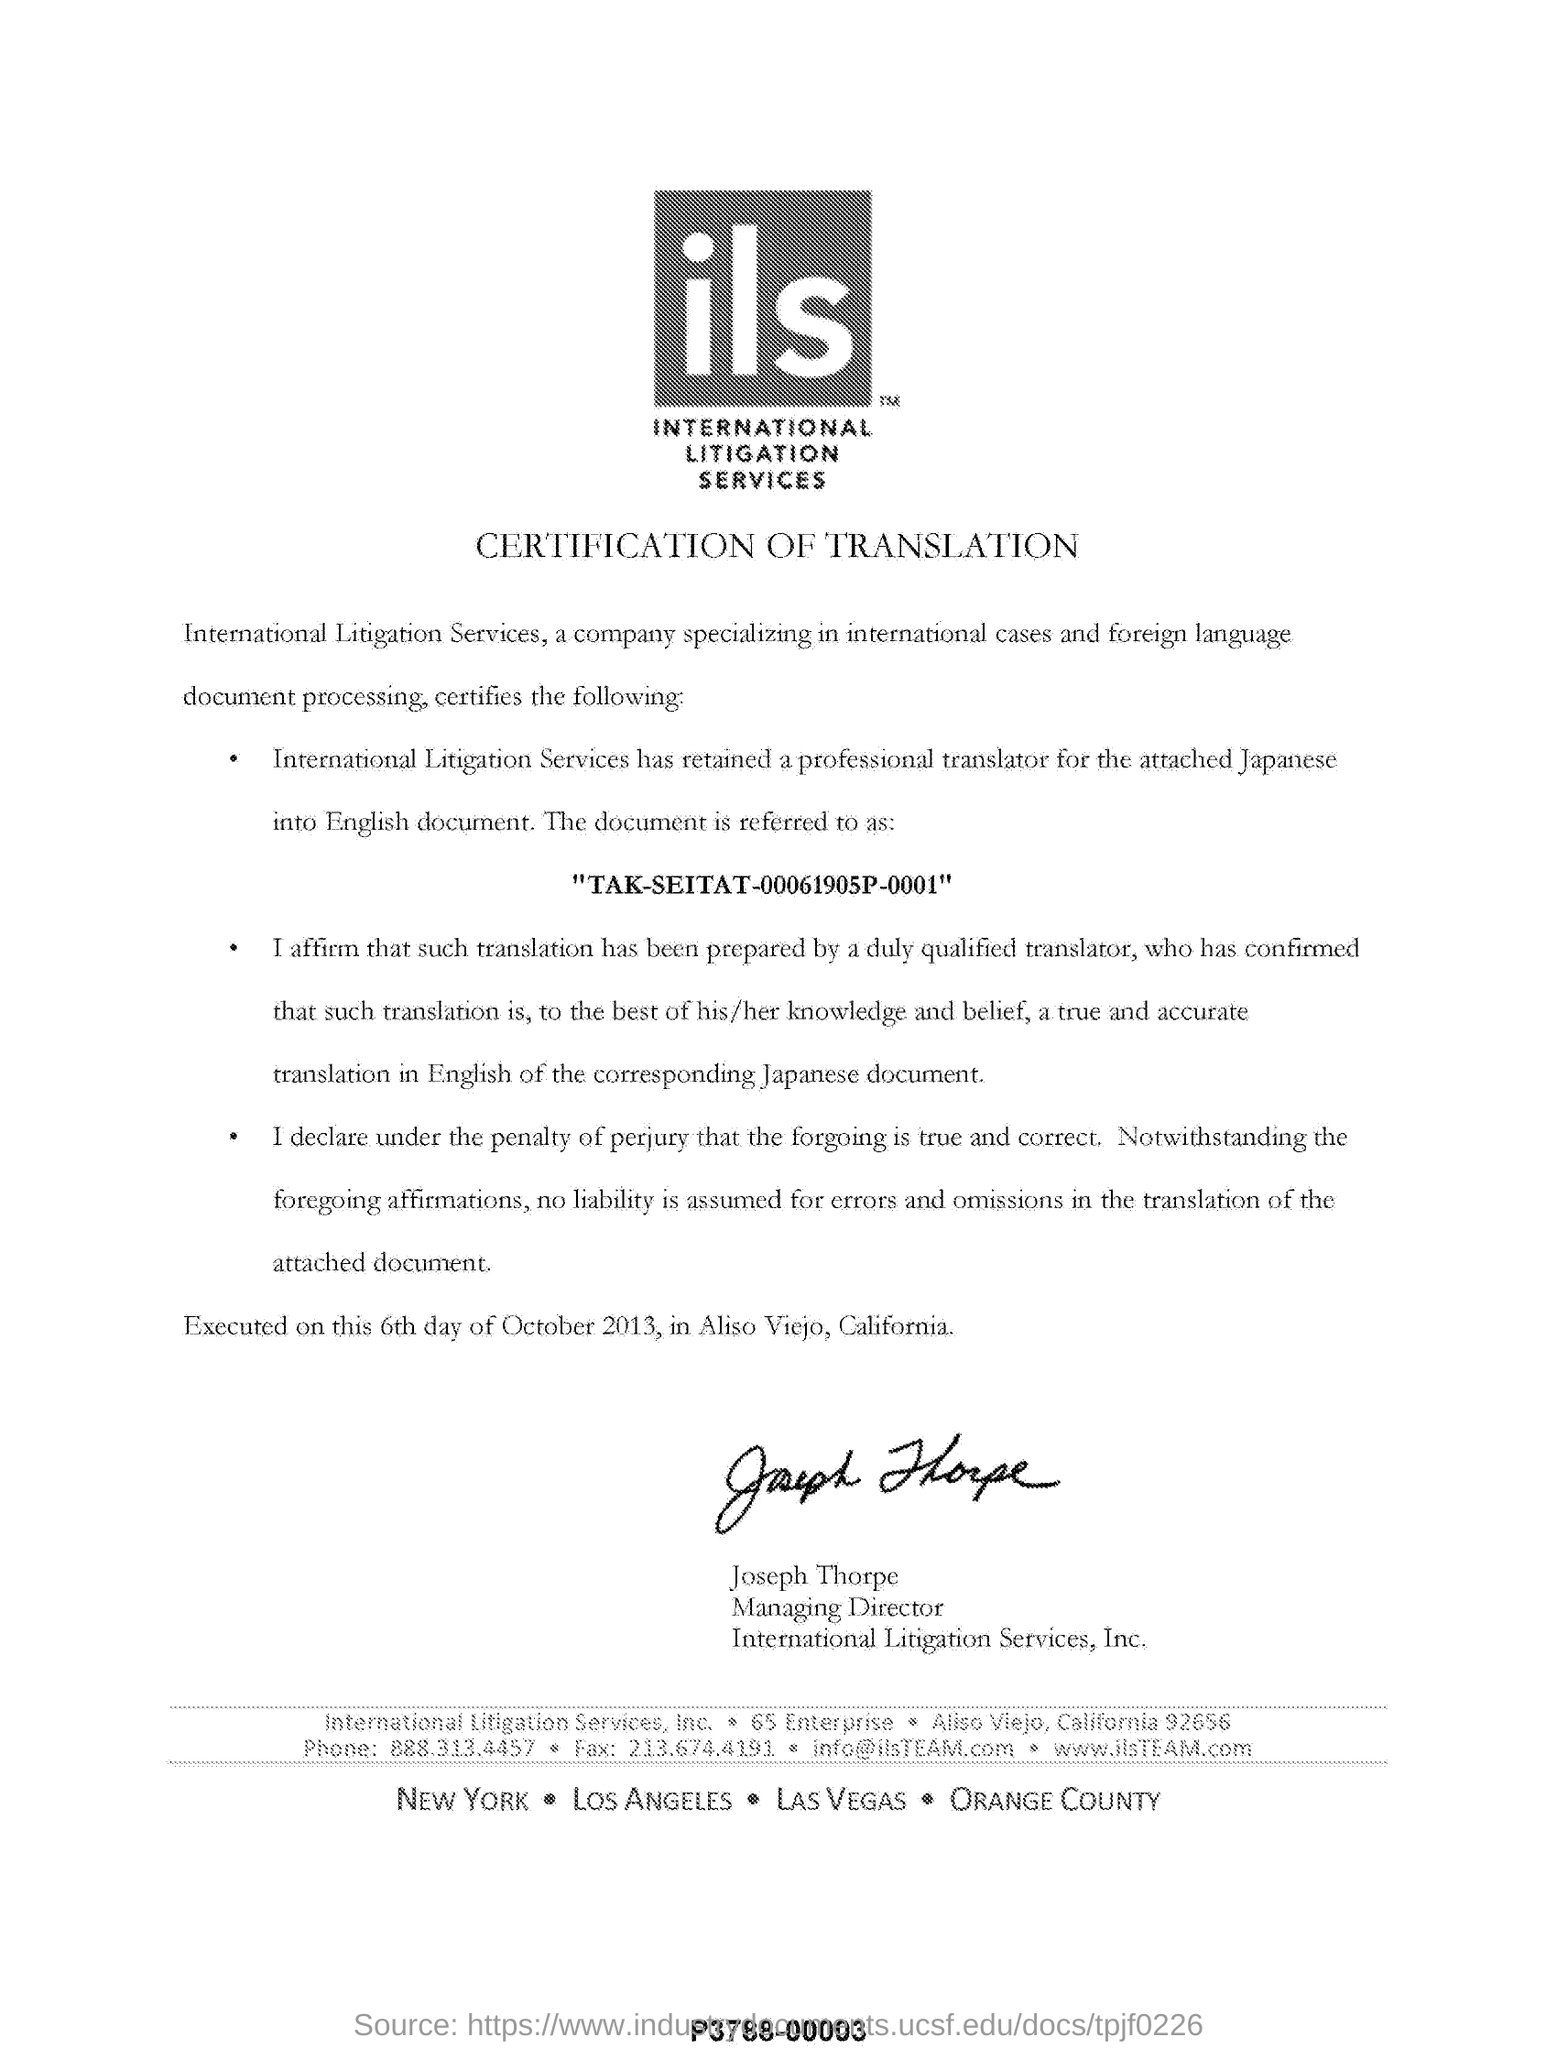Identify some key points in this picture. The managing director of International Litigation Services, Inc. is Joseph Thorpe. According to the document, a certification of translation is mentioned. International litigation services, commonly referred to as ILS, is a comprehensive legal solution that provides support to clients involved in international disputes. 